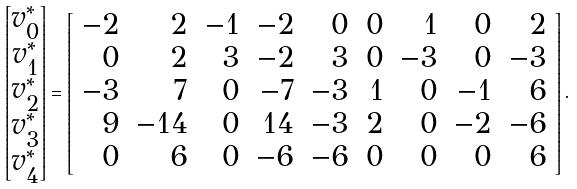Convert formula to latex. <formula><loc_0><loc_0><loc_500><loc_500>\begin{bmatrix} v _ { 0 } ^ { * } \\ v _ { 1 } ^ { * } \\ v _ { 2 } ^ { * } \\ v _ { 3 } ^ { * } \\ v _ { 4 } ^ { * } \\ \end{bmatrix} = \left [ \begin{array} { r r r r r r r r r } - 2 & 2 & - 1 & - 2 & 0 & 0 & 1 & 0 & 2 \\ 0 & 2 & 3 & - 2 & 3 & 0 & - 3 & 0 & - 3 \\ - 3 & 7 & 0 & - 7 & - 3 & 1 & 0 & - 1 & 6 \\ 9 & - 1 4 & 0 & 1 4 & - 3 & 2 & 0 & - 2 & - 6 \\ 0 & 6 & 0 & - 6 & - 6 & 0 & 0 & 0 & 6 \\ \end{array} \right ] .</formula> 